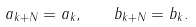<formula> <loc_0><loc_0><loc_500><loc_500>a _ { k + N } = a _ { k } , \quad b _ { k + N } = b _ { k } .</formula> 